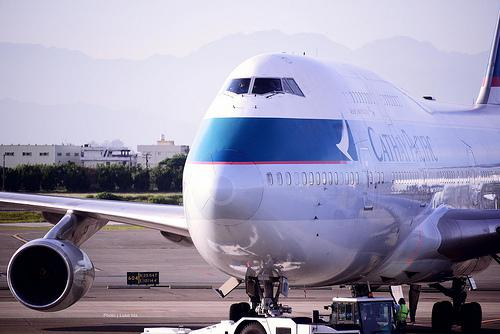Question: who controls the aircraft?
Choices:
A. The co-pilot.
B. The pilot.
C. The trainee.
D. The officer.
Answer with the letter. Answer: B Question: what company owns the plane?
Choices:
A. Cathay Pacific.
B. Delta Airlines.
C. The US military.
D. Northwest Airlines.
Answer with the letter. Answer: A Question: where are the jet engines?
Choices:
A. Inside the plane.
B. Beneath the plane.
C. On the side of the plane.
D. Under each wing.
Answer with the letter. Answer: D 